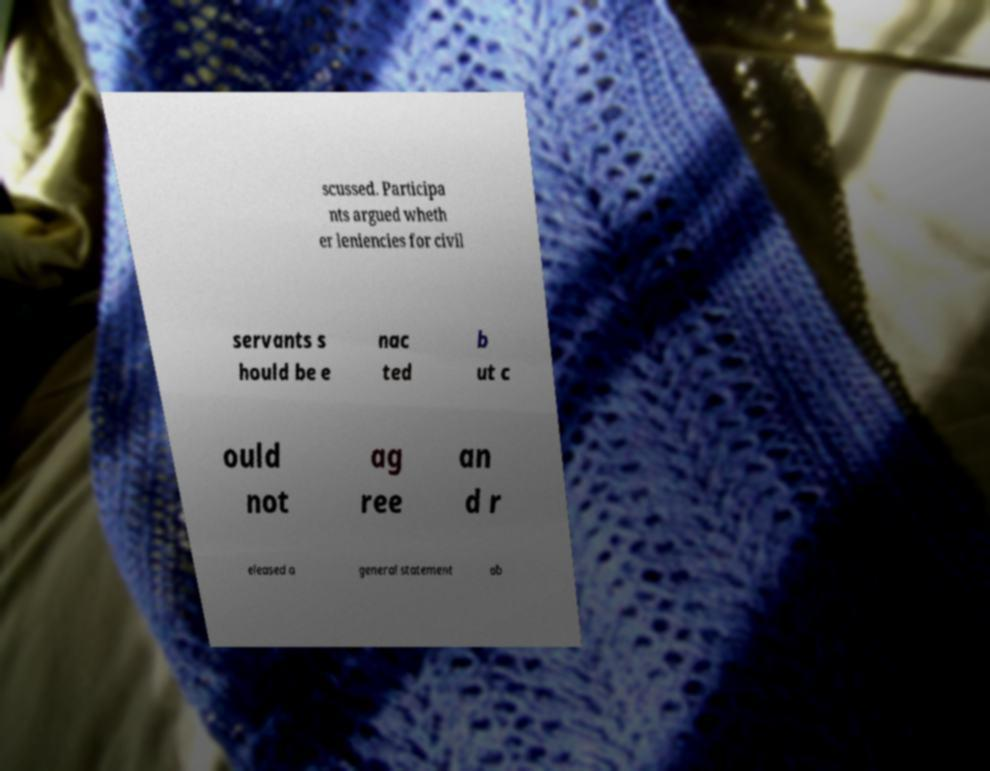For documentation purposes, I need the text within this image transcribed. Could you provide that? scussed. Participa nts argued wheth er leniencies for civil servants s hould be e nac ted b ut c ould not ag ree an d r eleased a general statement ab 